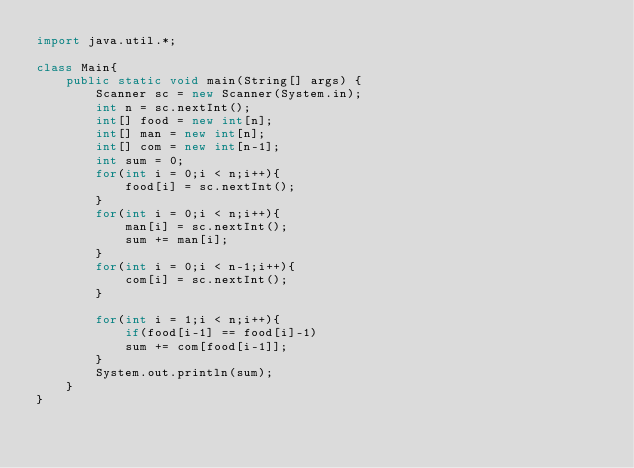Convert code to text. <code><loc_0><loc_0><loc_500><loc_500><_Java_>import java.util.*;

class Main{
    public static void main(String[] args) {
        Scanner sc = new Scanner(System.in);
        int n = sc.nextInt();
        int[] food = new int[n];
        int[] man = new int[n];
        int[] com = new int[n-1];
        int sum = 0;
        for(int i = 0;i < n;i++){
            food[i] = sc.nextInt();
        }
        for(int i = 0;i < n;i++){
            man[i] = sc.nextInt();
            sum += man[i];
        }
        for(int i = 0;i < n-1;i++){
            com[i] = sc.nextInt();
        }

        for(int i = 1;i < n;i++){
            if(food[i-1] == food[i]-1)
            sum += com[food[i-1]];
        }
        System.out.println(sum);
    }
}</code> 